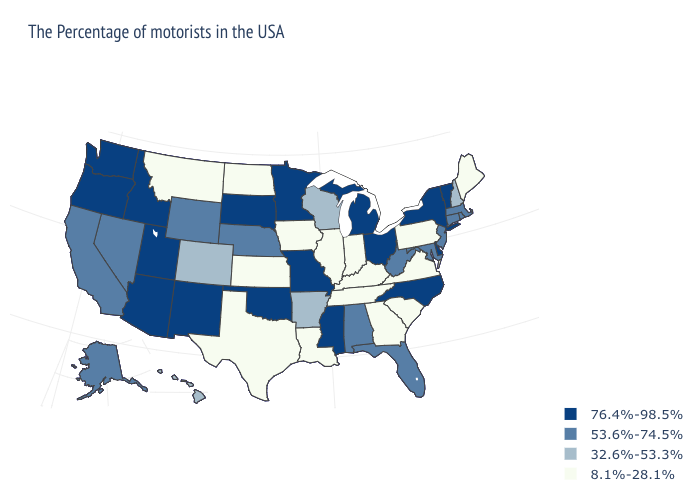Among the states that border Pennsylvania , which have the highest value?
Be succinct. New York, Delaware, Ohio. Name the states that have a value in the range 32.6%-53.3%?
Keep it brief. New Hampshire, Wisconsin, Arkansas, Colorado, Hawaii. What is the highest value in the South ?
Quick response, please. 76.4%-98.5%. Name the states that have a value in the range 32.6%-53.3%?
Be succinct. New Hampshire, Wisconsin, Arkansas, Colorado, Hawaii. What is the value of Virginia?
Keep it brief. 8.1%-28.1%. What is the value of Washington?
Short answer required. 76.4%-98.5%. Does Arkansas have a higher value than Virginia?
Answer briefly. Yes. What is the highest value in states that border Alabama?
Be succinct. 76.4%-98.5%. What is the value of Connecticut?
Answer briefly. 53.6%-74.5%. Does the first symbol in the legend represent the smallest category?
Give a very brief answer. No. What is the value of Michigan?
Answer briefly. 76.4%-98.5%. Does Minnesota have a higher value than Utah?
Short answer required. No. What is the value of Delaware?
Keep it brief. 76.4%-98.5%. What is the lowest value in the USA?
Quick response, please. 8.1%-28.1%. Does Utah have a higher value than Colorado?
Quick response, please. Yes. 